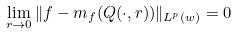Convert formula to latex. <formula><loc_0><loc_0><loc_500><loc_500>\lim _ { r \to 0 } \| f - m _ { f } ( Q ( \cdot , r ) ) \| _ { L ^ { p } ( w ) } = 0</formula> 